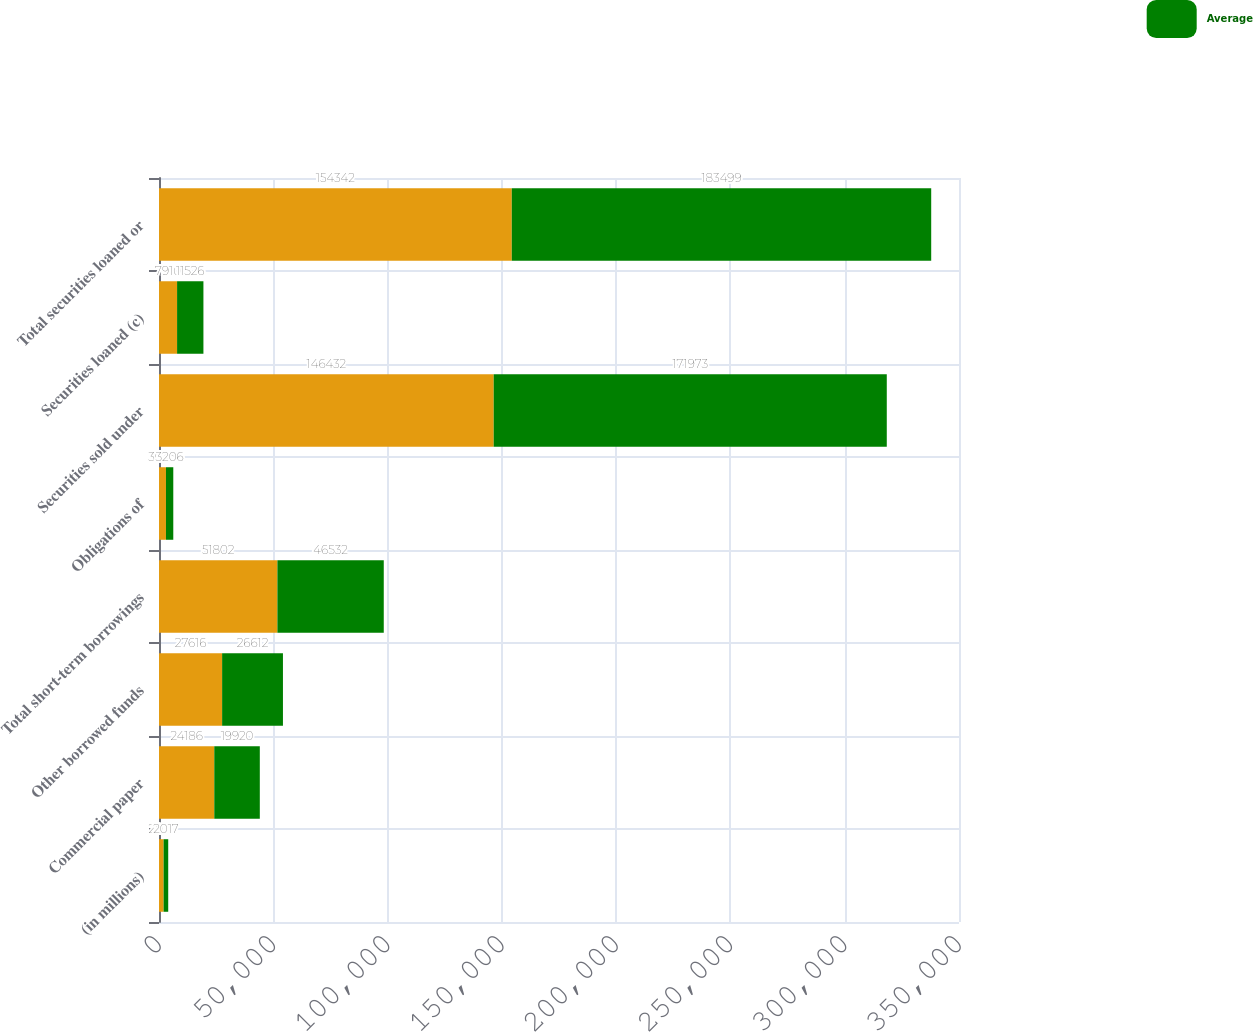<chart> <loc_0><loc_0><loc_500><loc_500><stacked_bar_chart><ecel><fcel>(in millions)<fcel>Commercial paper<fcel>Other borrowed funds<fcel>Total short-term borrowings<fcel>Obligations of<fcel>Securities sold under<fcel>Securities loaned (c)<fcel>Total securities loaned or<nl><fcel>nan<fcel>2017<fcel>24186<fcel>27616<fcel>51802<fcel>3045<fcel>146432<fcel>7910<fcel>154342<nl><fcel>Average<fcel>2017<fcel>19920<fcel>26612<fcel>46532<fcel>3206<fcel>171973<fcel>11526<fcel>183499<nl></chart> 